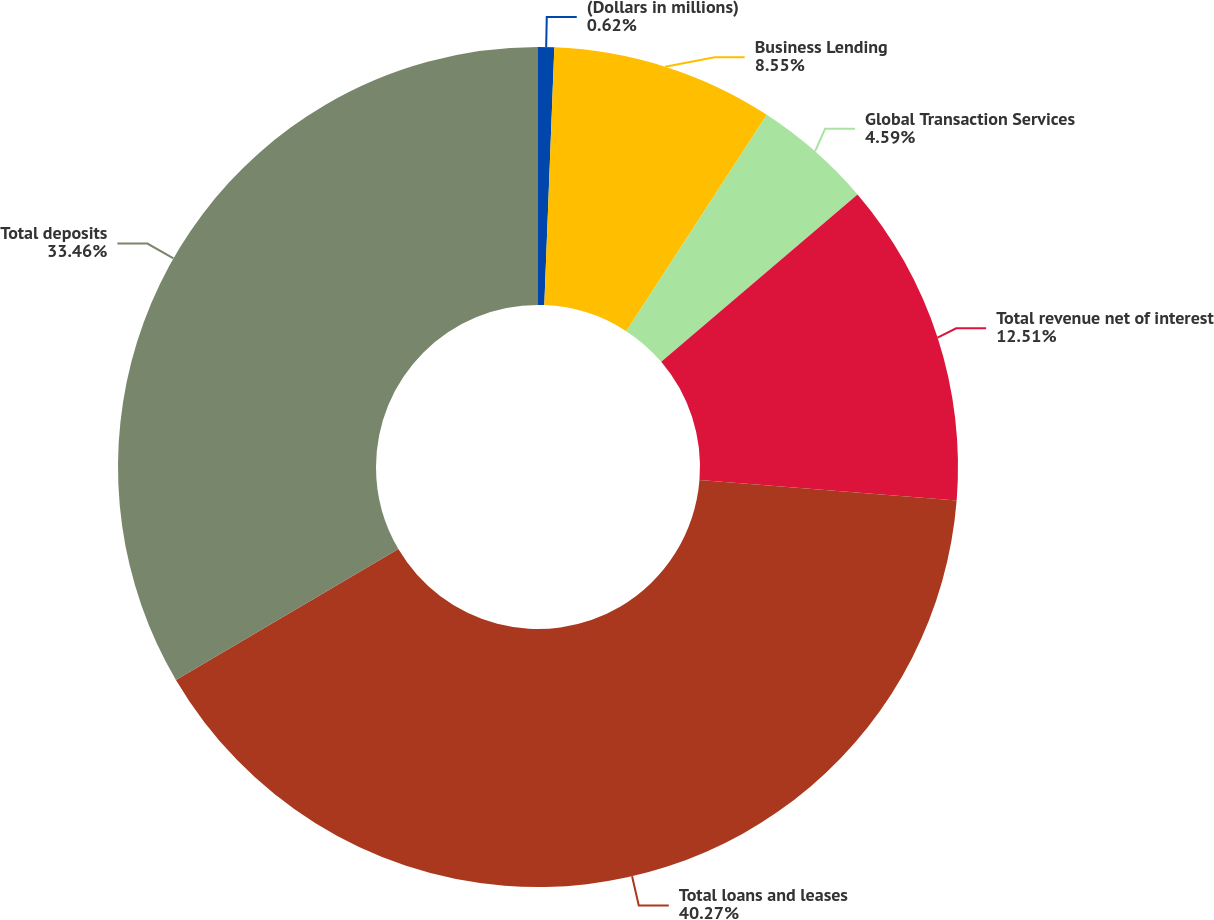Convert chart to OTSL. <chart><loc_0><loc_0><loc_500><loc_500><pie_chart><fcel>(Dollars in millions)<fcel>Business Lending<fcel>Global Transaction Services<fcel>Total revenue net of interest<fcel>Total loans and leases<fcel>Total deposits<nl><fcel>0.62%<fcel>8.55%<fcel>4.59%<fcel>12.51%<fcel>40.27%<fcel>33.46%<nl></chart> 